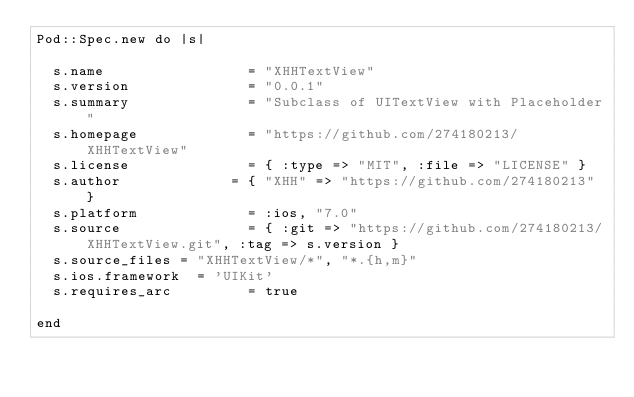<code> <loc_0><loc_0><loc_500><loc_500><_Ruby_>Pod::Spec.new do |s|

  s.name                 = "XHHTextView"
  s.version              = "0.0.1"
  s.summary              = "Subclass of UITextView with Placeholder"
  s.homepage             = "https://github.com/274180213/XHHTextView"
  s.license              = { :type => "MIT", :file => "LICENSE" }
  s.author             = { "XHH" => "https://github.com/274180213" }
  s.platform             = :ios, "7.0"
  s.source               = { :git => "https://github.com/274180213/XHHTextView.git", :tag => s.version }
  s.source_files = "XHHTextView/*", "*.{h,m}" 
  s.ios.framework  = 'UIKit'
  s.requires_arc         = true

end

</code> 